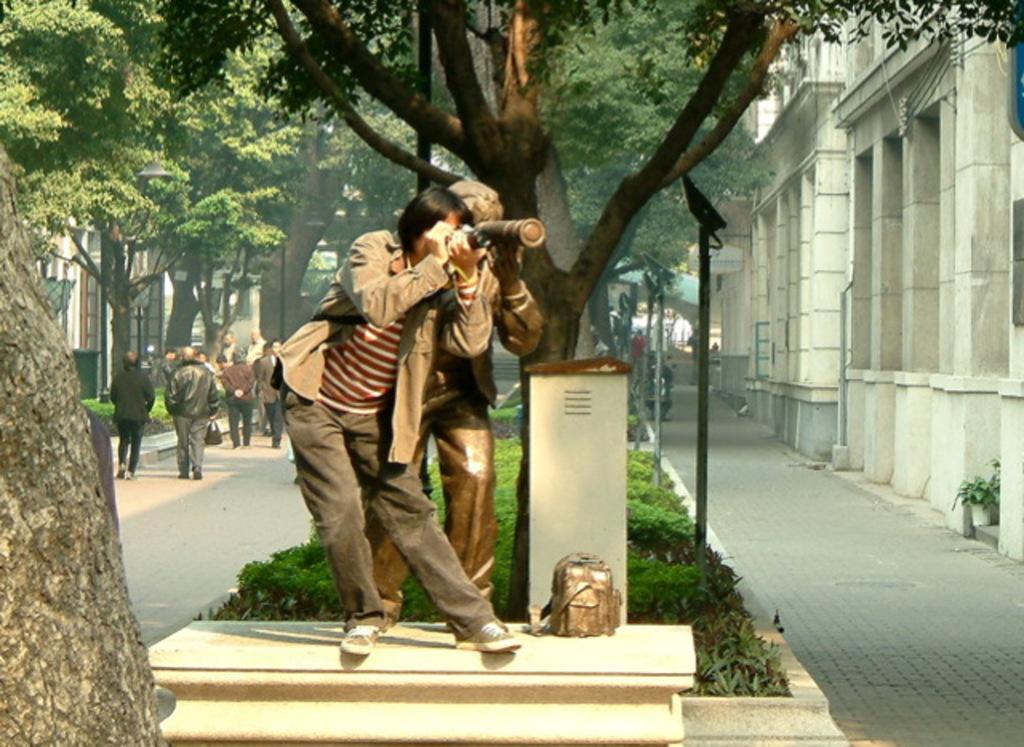Describe this image in one or two sentences. In the picture I can see the statue of a person on the marble bench and there is a man standing on the side of the statue and he is holding the camera. I can see the trunk of a tree on the left side. I can see a few people walking on the road on the left side. There are buildings on the left side and the right side as well. In the background, I can see the trees. 